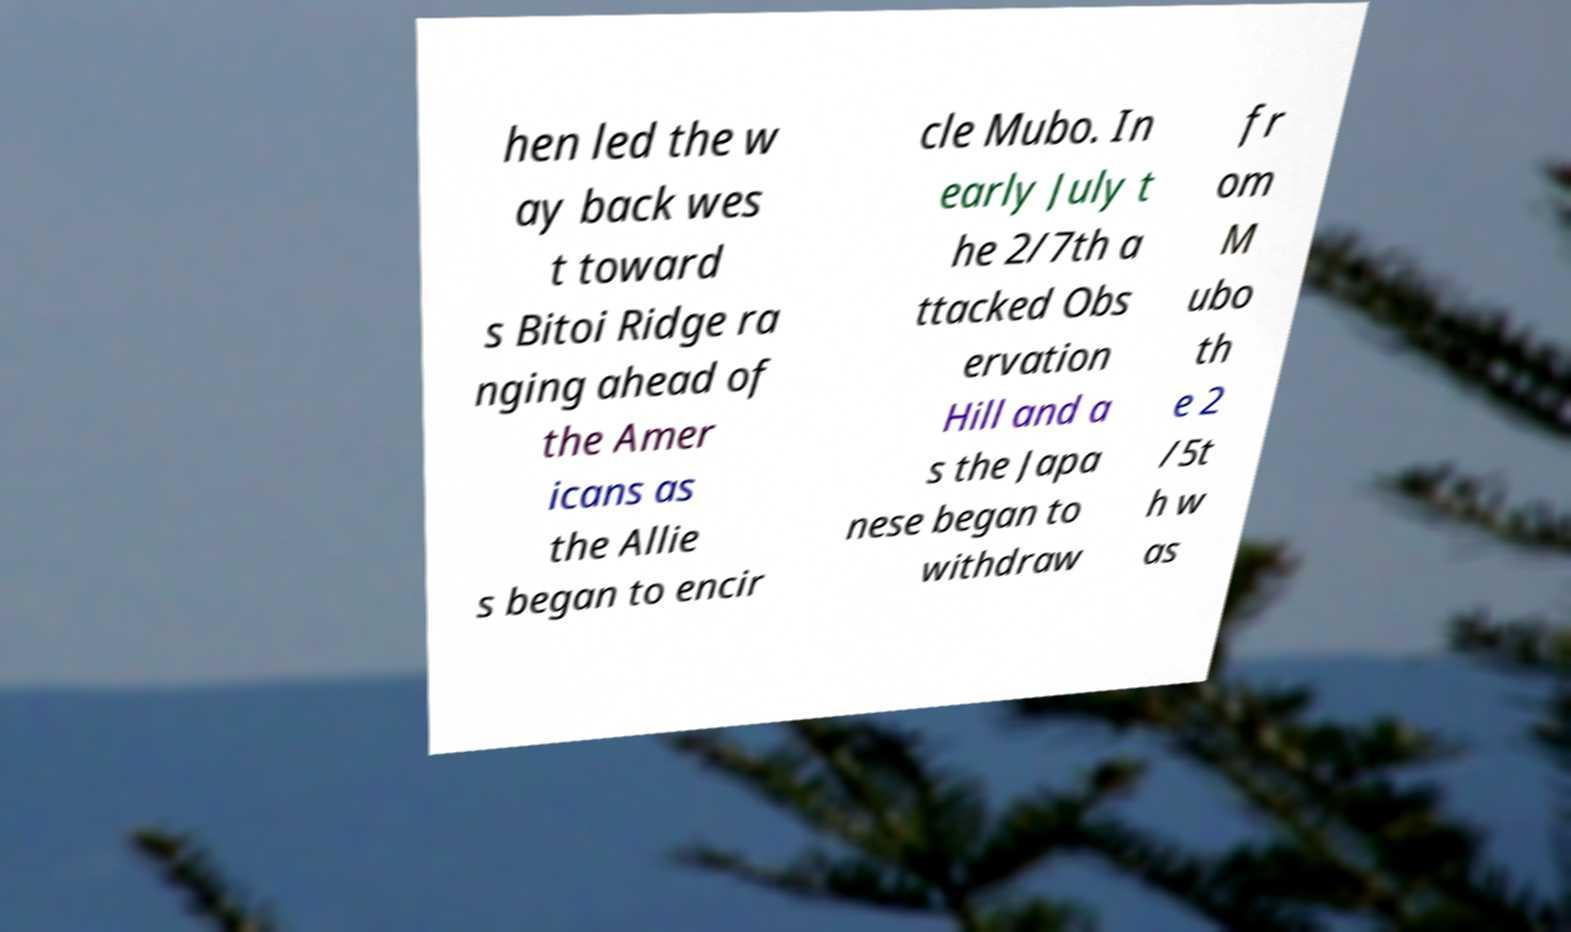I need the written content from this picture converted into text. Can you do that? hen led the w ay back wes t toward s Bitoi Ridge ra nging ahead of the Amer icans as the Allie s began to encir cle Mubo. In early July t he 2/7th a ttacked Obs ervation Hill and a s the Japa nese began to withdraw fr om M ubo th e 2 /5t h w as 